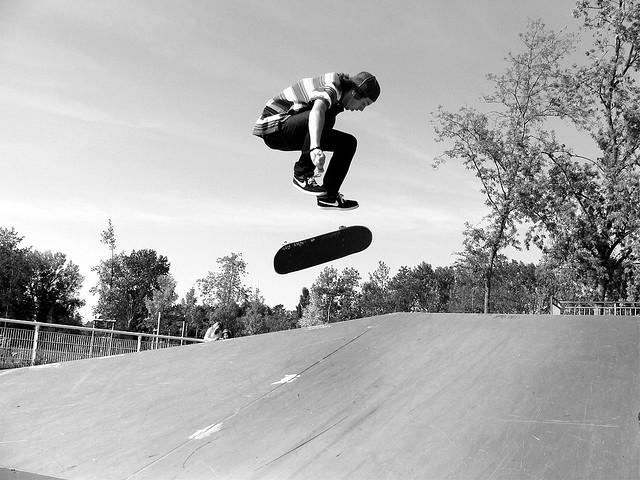What kind of shoes is the skater wearing?

Choices:
A) vans
B) puma
C) airwalk
D) nike nike 